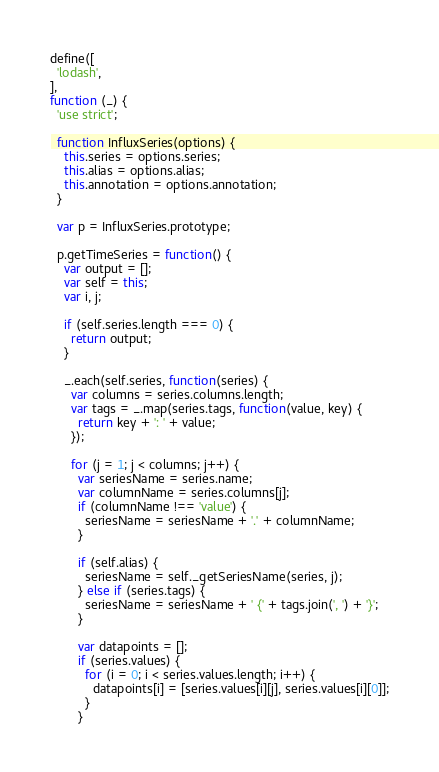<code> <loc_0><loc_0><loc_500><loc_500><_JavaScript_>define([
  'lodash',
],
function (_) {
  'use strict';

  function InfluxSeries(options) {
    this.series = options.series;
    this.alias = options.alias;
    this.annotation = options.annotation;
  }

  var p = InfluxSeries.prototype;

  p.getTimeSeries = function() {
    var output = [];
    var self = this;
    var i, j;

    if (self.series.length === 0) {
      return output;
    }

    _.each(self.series, function(series) {
      var columns = series.columns.length;
      var tags = _.map(series.tags, function(value, key) {
        return key + ': ' + value;
      });

      for (j = 1; j < columns; j++) {
        var seriesName = series.name;
        var columnName = series.columns[j];
        if (columnName !== 'value') {
          seriesName = seriesName + '.' + columnName;
        }

        if (self.alias) {
          seriesName = self._getSeriesName(series, j);
        } else if (series.tags) {
          seriesName = seriesName + ' {' + tags.join(', ') + '}';
        }

        var datapoints = [];
        if (series.values) {
          for (i = 0; i < series.values.length; i++) {
            datapoints[i] = [series.values[i][j], series.values[i][0]];
          }
        }
</code> 